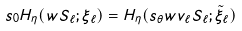<formula> <loc_0><loc_0><loc_500><loc_500>s _ { 0 } H _ { \eta } ( w S _ { \ell } ; \xi _ { \ell } ) & = H _ { \eta } ( s _ { \theta } w v _ { \ell } S _ { \ell } ; \tilde { \xi } _ { \ell } )</formula> 